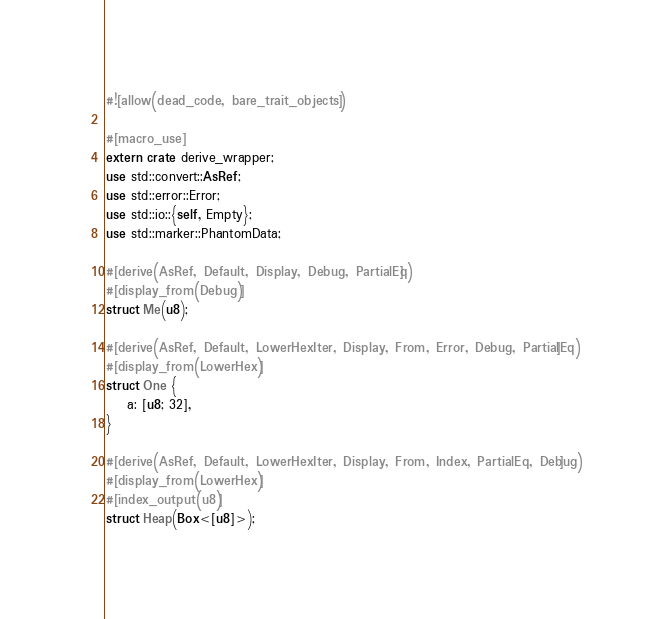Convert code to text. <code><loc_0><loc_0><loc_500><loc_500><_Rust_>#![allow(dead_code, bare_trait_objects)]

#[macro_use]
extern crate derive_wrapper;
use std::convert::AsRef;
use std::error::Error;
use std::io::{self, Empty};
use std::marker::PhantomData;

#[derive(AsRef, Default, Display, Debug, PartialEq)]
#[display_from(Debug)]
struct Me(u8);

#[derive(AsRef, Default, LowerHexIter, Display, From, Error, Debug, PartialEq)]
#[display_from(LowerHex)]
struct One {
    a: [u8; 32],
}

#[derive(AsRef, Default, LowerHexIter, Display, From, Index, PartialEq, Debug)]
#[display_from(LowerHex)]
#[index_output(u8)]
struct Heap(Box<[u8]>);
</code> 